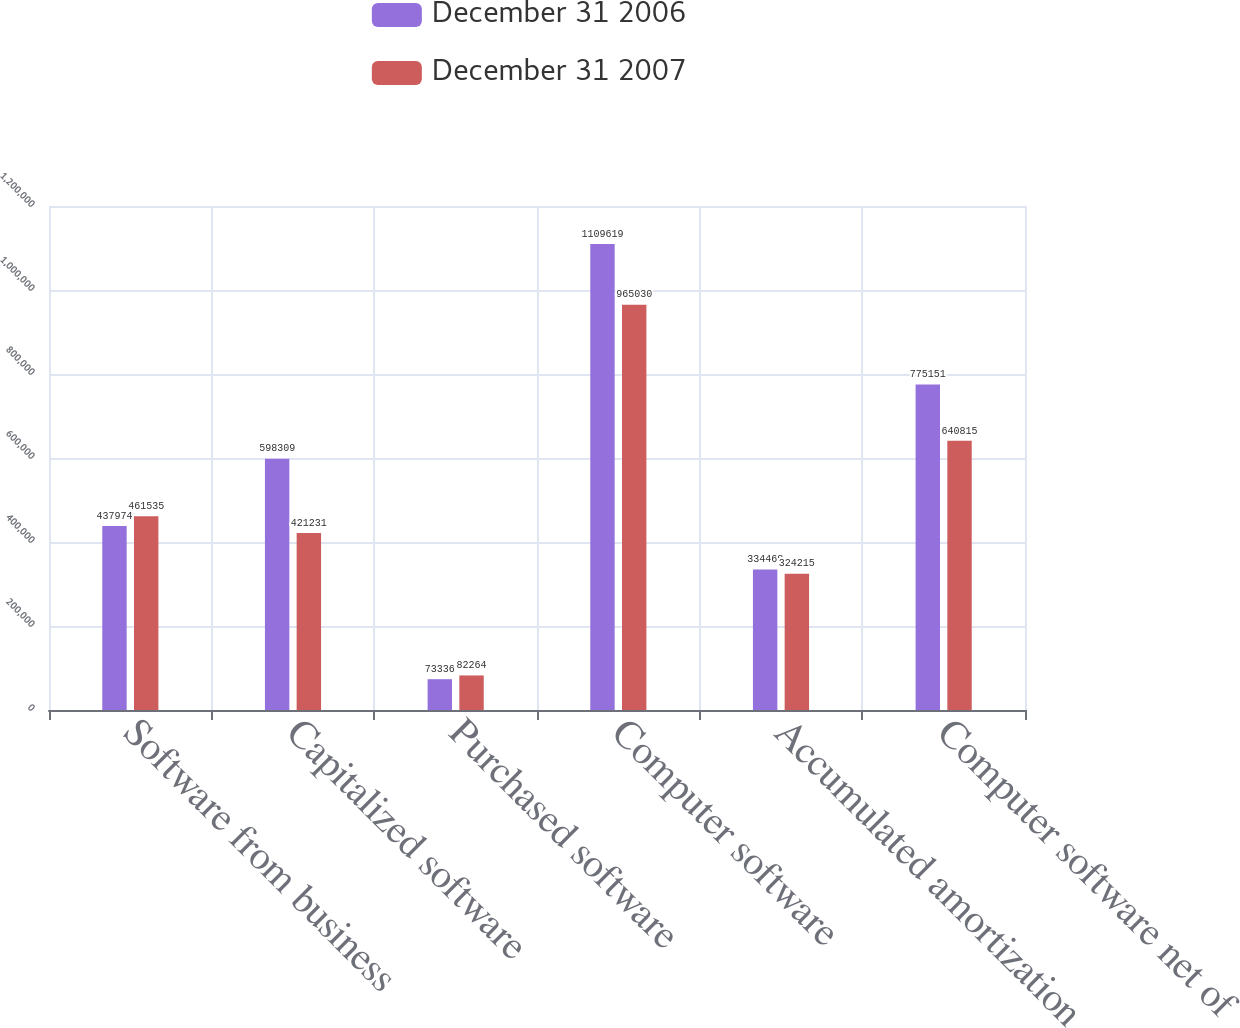Convert chart to OTSL. <chart><loc_0><loc_0><loc_500><loc_500><stacked_bar_chart><ecel><fcel>Software from business<fcel>Capitalized software<fcel>Purchased software<fcel>Computer software<fcel>Accumulated amortization<fcel>Computer software net of<nl><fcel>December 31 2006<fcel>437974<fcel>598309<fcel>73336<fcel>1.10962e+06<fcel>334468<fcel>775151<nl><fcel>December 31 2007<fcel>461535<fcel>421231<fcel>82264<fcel>965030<fcel>324215<fcel>640815<nl></chart> 